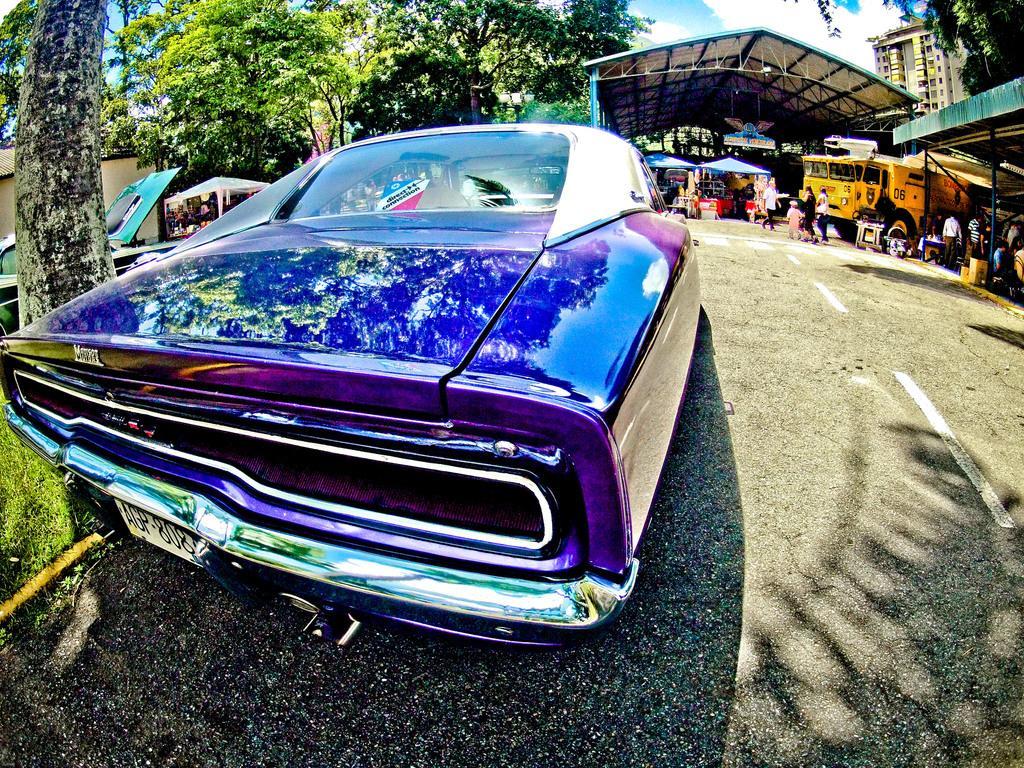Describe this image in one or two sentences. In this image in the foreground there is one car, and in the background there are some vehicles, shelter, building, trees and some other objects. At the bottom there is road. 